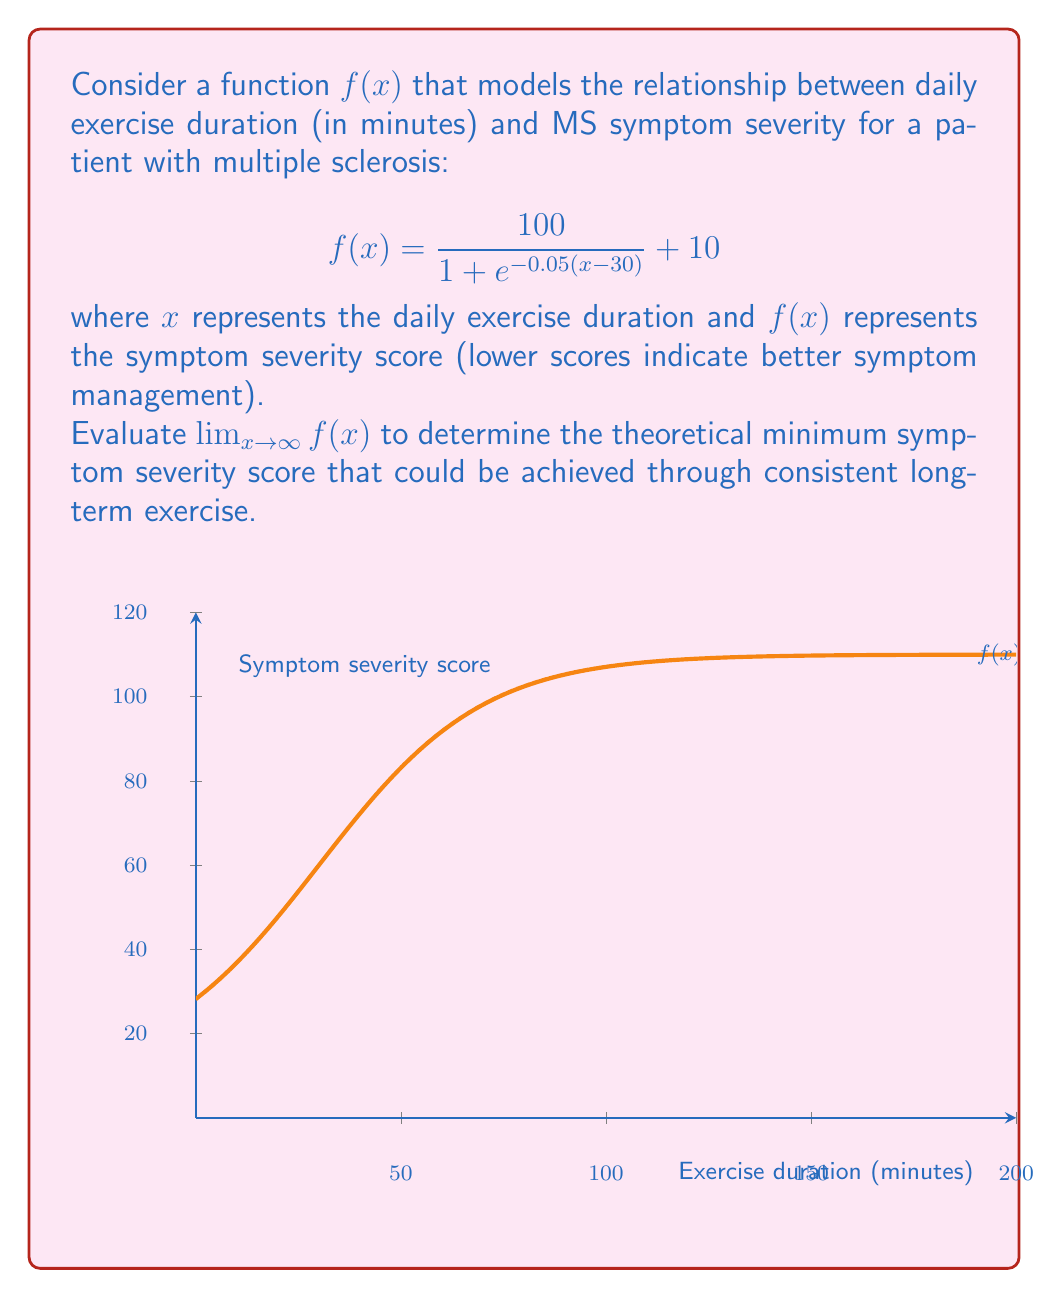Teach me how to tackle this problem. Let's approach this step-by-step:

1) We need to evaluate $\lim_{x \to \infty} f(x)$ where $f(x) = \frac{100}{1 + e^{-0.05(x-30)}} + 10$

2) As $x$ approaches infinity, $-0.05(x-30)$ approaches negative infinity.

3) Therefore, $e^{-0.05(x-30)}$ approaches 0 as $x$ approaches infinity.

4) This means that $1 + e^{-0.05(x-30)}$ approaches 1 as $x$ approaches infinity.

5) So, the fraction $\frac{100}{1 + e^{-0.05(x-30)}}$ approaches $\frac{100}{1} = 100$ as $x$ approaches infinity.

6) Adding the constant 10, we get:

   $\lim_{x \to \infty} f(x) = \lim_{x \to \infty} (\frac{100}{1 + e^{-0.05(x-30)}} + 10) = 100 + 10 = 110$

Therefore, the theoretical minimum symptom severity score that could be achieved through consistent long-term exercise is 110.
Answer: 110 